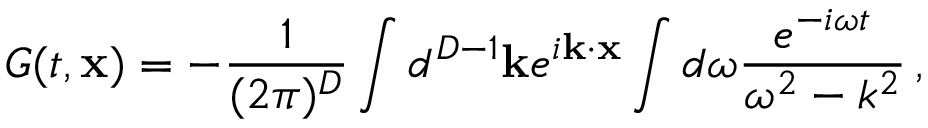Convert formula to latex. <formula><loc_0><loc_0><loc_500><loc_500>G ( t , { x } ) = - \frac { 1 } { ( 2 \pi ) ^ { D } } \int d ^ { D - 1 } { k } e ^ { i { k } \cdot { x } } \int d \omega \frac { e ^ { - i \omega t } } { \omega ^ { 2 } - k ^ { 2 } } \, ,</formula> 